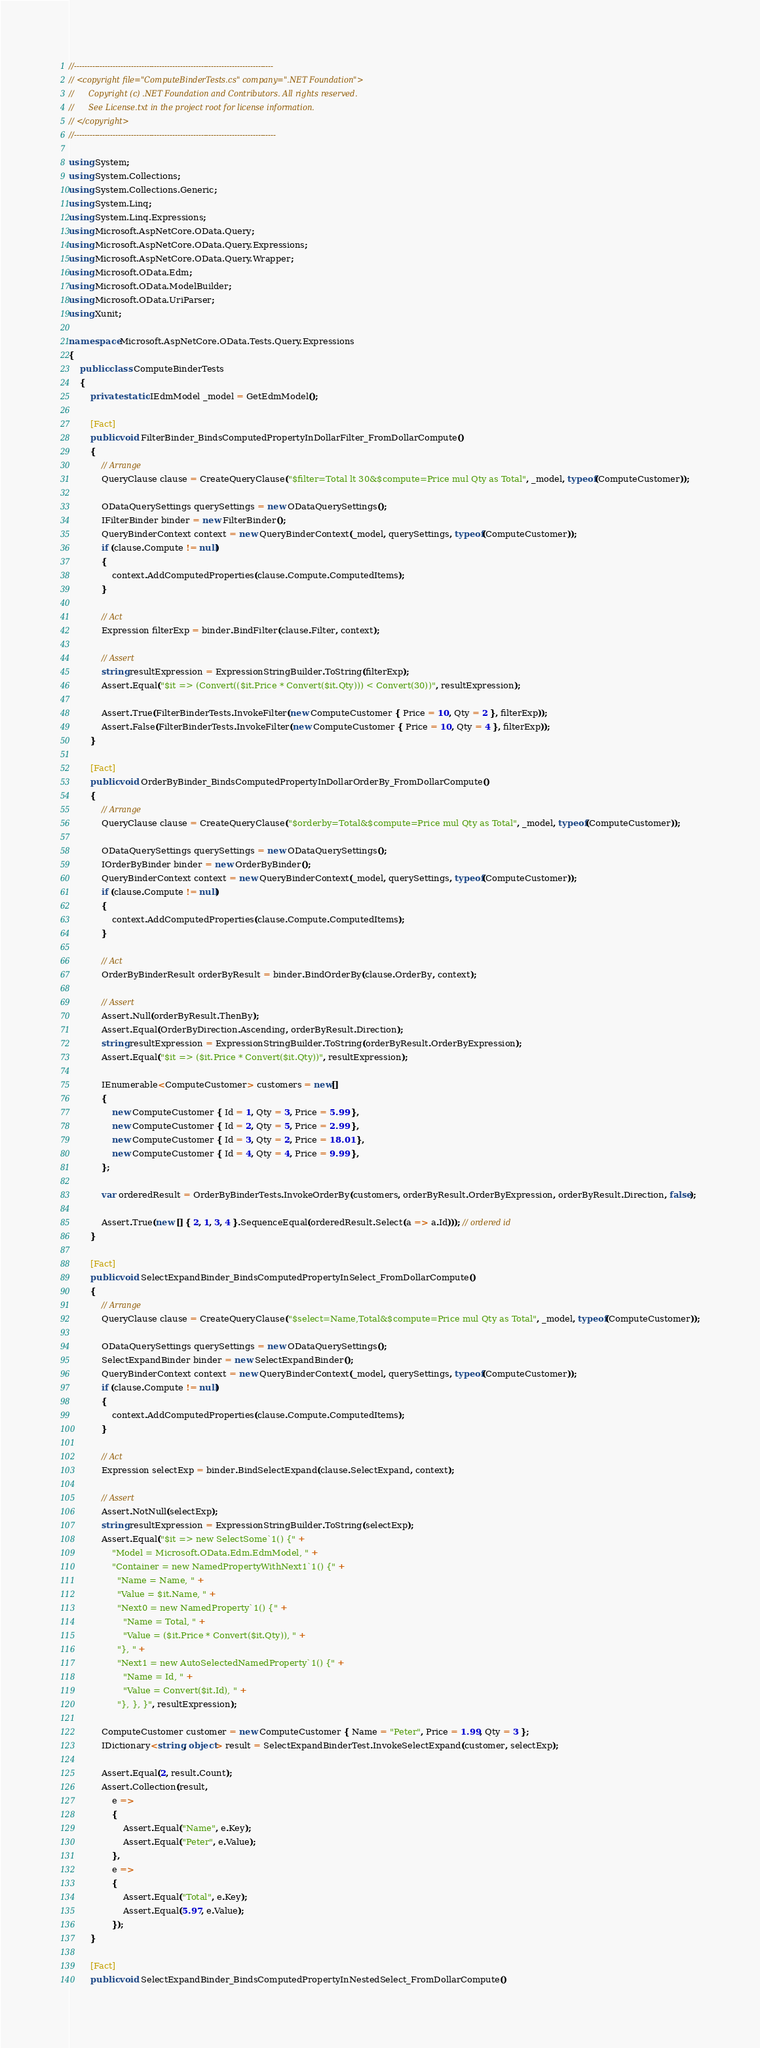Convert code to text. <code><loc_0><loc_0><loc_500><loc_500><_C#_>//-----------------------------------------------------------------------------
// <copyright file="ComputeBinderTests.cs" company=".NET Foundation">
//      Copyright (c) .NET Foundation and Contributors. All rights reserved.
//      See License.txt in the project root for license information.
// </copyright>
//------------------------------------------------------------------------------

using System;
using System.Collections;
using System.Collections.Generic;
using System.Linq;
using System.Linq.Expressions;
using Microsoft.AspNetCore.OData.Query;
using Microsoft.AspNetCore.OData.Query.Expressions;
using Microsoft.AspNetCore.OData.Query.Wrapper;
using Microsoft.OData.Edm;
using Microsoft.OData.ModelBuilder;
using Microsoft.OData.UriParser;
using Xunit;

namespace Microsoft.AspNetCore.OData.Tests.Query.Expressions
{
    public class ComputeBinderTests
    {
        private static IEdmModel _model = GetEdmModel();

        [Fact]
        public void FilterBinder_BindsComputedPropertyInDollarFilter_FromDollarCompute()
        {
            // Arrange
            QueryClause clause = CreateQueryClause("$filter=Total lt 30&$compute=Price mul Qty as Total", _model, typeof(ComputeCustomer));

            ODataQuerySettings querySettings = new ODataQuerySettings();
            IFilterBinder binder = new FilterBinder();
            QueryBinderContext context = new QueryBinderContext(_model, querySettings, typeof(ComputeCustomer));
            if (clause.Compute != null)
            {
                context.AddComputedProperties(clause.Compute.ComputedItems);
            }

            // Act
            Expression filterExp = binder.BindFilter(clause.Filter, context);

            // Assert
            string resultExpression = ExpressionStringBuilder.ToString(filterExp);
            Assert.Equal("$it => (Convert(($it.Price * Convert($it.Qty))) < Convert(30))", resultExpression);

            Assert.True(FilterBinderTests.InvokeFilter(new ComputeCustomer { Price = 10, Qty = 2 }, filterExp));
            Assert.False(FilterBinderTests.InvokeFilter(new ComputeCustomer { Price = 10, Qty = 4 }, filterExp));
        }

        [Fact]
        public void OrderByBinder_BindsComputedPropertyInDollarOrderBy_FromDollarCompute()
        {
            // Arrange
            QueryClause clause = CreateQueryClause("$orderby=Total&$compute=Price mul Qty as Total", _model, typeof(ComputeCustomer));

            ODataQuerySettings querySettings = new ODataQuerySettings();
            IOrderByBinder binder = new OrderByBinder();
            QueryBinderContext context = new QueryBinderContext(_model, querySettings, typeof(ComputeCustomer));
            if (clause.Compute != null)
            {
                context.AddComputedProperties(clause.Compute.ComputedItems);
            }

            // Act
            OrderByBinderResult orderByResult = binder.BindOrderBy(clause.OrderBy, context);

            // Assert
            Assert.Null(orderByResult.ThenBy);
            Assert.Equal(OrderByDirection.Ascending, orderByResult.Direction);
            string resultExpression = ExpressionStringBuilder.ToString(orderByResult.OrderByExpression);
            Assert.Equal("$it => ($it.Price * Convert($it.Qty))", resultExpression);

            IEnumerable<ComputeCustomer> customers = new[]
            {
                new ComputeCustomer { Id = 1, Qty = 3, Price = 5.99 },
                new ComputeCustomer { Id = 2, Qty = 5, Price = 2.99 },
                new ComputeCustomer { Id = 3, Qty = 2, Price = 18.01 },
                new ComputeCustomer { Id = 4, Qty = 4, Price = 9.99 },
            };

            var orderedResult = OrderByBinderTests.InvokeOrderBy(customers, orderByResult.OrderByExpression, orderByResult.Direction, false);

            Assert.True(new [] { 2, 1, 3, 4 }.SequenceEqual(orderedResult.Select(a => a.Id))); // ordered id
        }

        [Fact]
        public void SelectExpandBinder_BindsComputedPropertyInSelect_FromDollarCompute()
        {
            // Arrange
            QueryClause clause = CreateQueryClause("$select=Name,Total&$compute=Price mul Qty as Total", _model, typeof(ComputeCustomer));

            ODataQuerySettings querySettings = new ODataQuerySettings();
            SelectExpandBinder binder = new SelectExpandBinder();
            QueryBinderContext context = new QueryBinderContext(_model, querySettings, typeof(ComputeCustomer));
            if (clause.Compute != null)
            {
                context.AddComputedProperties(clause.Compute.ComputedItems);
            }

            // Act
            Expression selectExp = binder.BindSelectExpand(clause.SelectExpand, context);

            // Assert
            Assert.NotNull(selectExp);
            string resultExpression = ExpressionStringBuilder.ToString(selectExp);
            Assert.Equal("$it => new SelectSome`1() {" +
                "Model = Microsoft.OData.Edm.EdmModel, " +
                "Container = new NamedPropertyWithNext1`1() {" +
                  "Name = Name, " +
                  "Value = $it.Name, " +
                  "Next0 = new NamedProperty`1() {" +
                    "Name = Total, " +
                    "Value = ($it.Price * Convert($it.Qty)), " +
                  "}, " +
                  "Next1 = new AutoSelectedNamedProperty`1() {" +
                    "Name = Id, " +
                    "Value = Convert($it.Id), " +
                  "}, }, }", resultExpression);

            ComputeCustomer customer = new ComputeCustomer { Name = "Peter", Price = 1.99, Qty = 3 };
            IDictionary<string, object> result = SelectExpandBinderTest.InvokeSelectExpand(customer, selectExp);

            Assert.Equal(2, result.Count);
            Assert.Collection(result,
                e =>
                {
                    Assert.Equal("Name", e.Key);
                    Assert.Equal("Peter", e.Value);
                },
                e =>
                {
                    Assert.Equal("Total", e.Key);
                    Assert.Equal(5.97, e.Value);
                });
        }

        [Fact]
        public void SelectExpandBinder_BindsComputedPropertyInNestedSelect_FromDollarCompute()</code> 